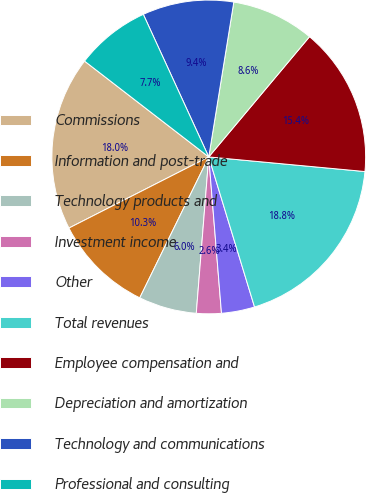<chart> <loc_0><loc_0><loc_500><loc_500><pie_chart><fcel>Commissions<fcel>Information and post-trade<fcel>Technology products and<fcel>Investment income<fcel>Other<fcel>Total revenues<fcel>Employee compensation and<fcel>Depreciation and amortization<fcel>Technology and communications<fcel>Professional and consulting<nl><fcel>17.95%<fcel>10.26%<fcel>5.98%<fcel>2.56%<fcel>3.42%<fcel>18.8%<fcel>15.38%<fcel>8.55%<fcel>9.4%<fcel>7.69%<nl></chart> 